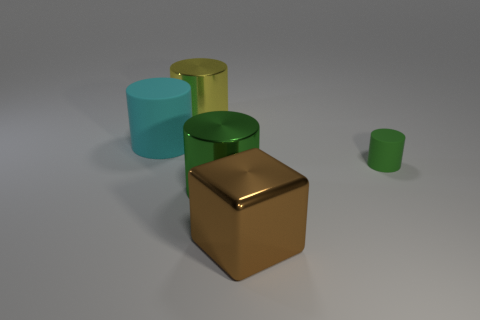Subtract 1 cylinders. How many cylinders are left? 3 Add 3 large yellow metallic cylinders. How many objects exist? 8 Subtract all cylinders. How many objects are left? 1 Subtract 0 gray cylinders. How many objects are left? 5 Subtract all large matte objects. Subtract all cyan matte cubes. How many objects are left? 4 Add 3 yellow shiny cylinders. How many yellow shiny cylinders are left? 4 Add 3 cyan things. How many cyan things exist? 4 